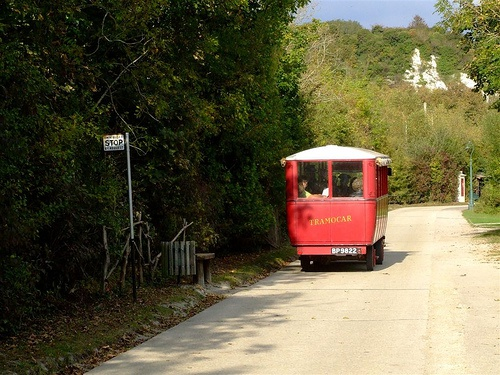Describe the objects in this image and their specific colors. I can see bus in black, salmon, maroon, and white tones, people in black, olive, maroon, and khaki tones, people in black and darkgreen tones, and people in black, maroon, and darkgreen tones in this image. 